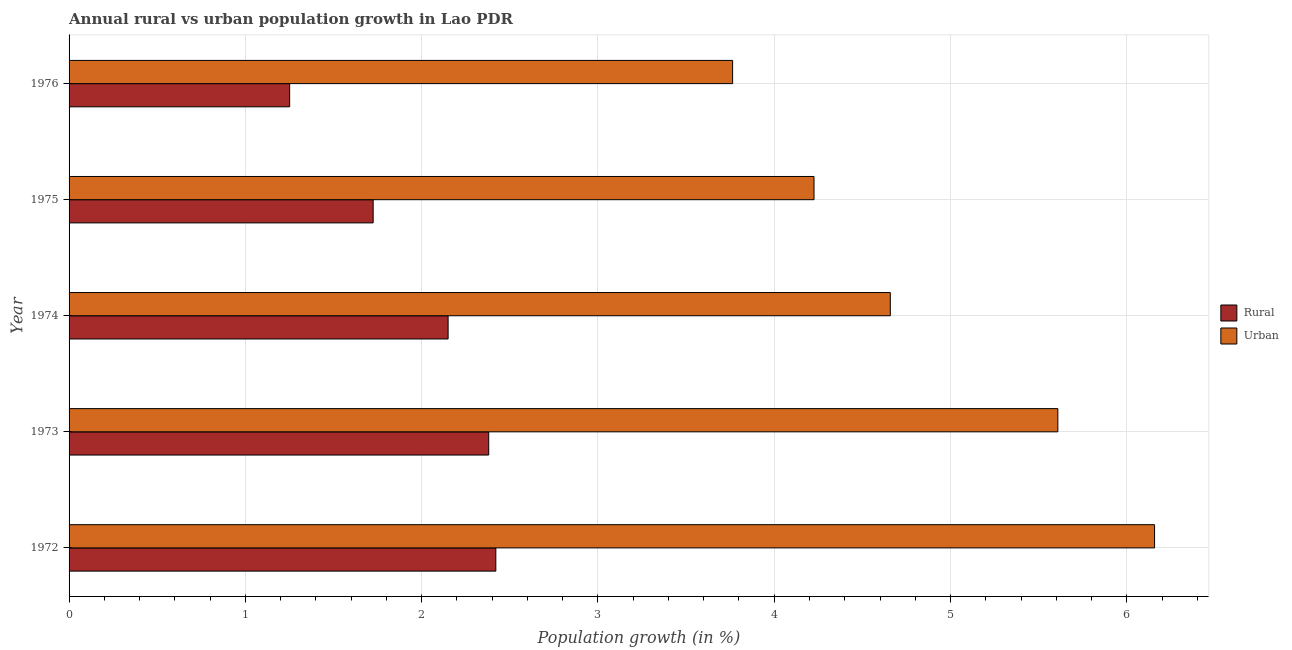How many different coloured bars are there?
Your answer should be compact. 2. How many groups of bars are there?
Make the answer very short. 5. Are the number of bars per tick equal to the number of legend labels?
Ensure brevity in your answer.  Yes. How many bars are there on the 5th tick from the top?
Your answer should be very brief. 2. What is the rural population growth in 1976?
Your answer should be compact. 1.25. Across all years, what is the maximum urban population growth?
Provide a succinct answer. 6.16. Across all years, what is the minimum urban population growth?
Your answer should be compact. 3.76. In which year was the urban population growth maximum?
Provide a short and direct response. 1972. In which year was the urban population growth minimum?
Offer a terse response. 1976. What is the total urban population growth in the graph?
Provide a succinct answer. 24.41. What is the difference between the rural population growth in 1974 and that in 1976?
Your answer should be very brief. 0.9. What is the difference between the urban population growth in 1975 and the rural population growth in 1976?
Your answer should be compact. 2.97. What is the average urban population growth per year?
Ensure brevity in your answer.  4.88. In the year 1976, what is the difference between the rural population growth and urban population growth?
Your response must be concise. -2.51. What is the ratio of the rural population growth in 1973 to that in 1975?
Your answer should be very brief. 1.38. What is the difference between the highest and the second highest urban population growth?
Your answer should be compact. 0.55. What is the difference between the highest and the lowest urban population growth?
Keep it short and to the point. 2.39. In how many years, is the urban population growth greater than the average urban population growth taken over all years?
Offer a terse response. 2. What does the 1st bar from the top in 1973 represents?
Your answer should be compact. Urban . What does the 1st bar from the bottom in 1974 represents?
Your response must be concise. Rural. How many bars are there?
Your answer should be very brief. 10. How many years are there in the graph?
Your answer should be very brief. 5. What is the difference between two consecutive major ticks on the X-axis?
Offer a very short reply. 1. Does the graph contain any zero values?
Provide a succinct answer. No. How are the legend labels stacked?
Your answer should be very brief. Vertical. What is the title of the graph?
Offer a very short reply. Annual rural vs urban population growth in Lao PDR. Does "Quasi money growth" appear as one of the legend labels in the graph?
Your answer should be very brief. No. What is the label or title of the X-axis?
Your response must be concise. Population growth (in %). What is the label or title of the Y-axis?
Provide a short and direct response. Year. What is the Population growth (in %) in Rural in 1972?
Your answer should be compact. 2.42. What is the Population growth (in %) of Urban  in 1972?
Your answer should be compact. 6.16. What is the Population growth (in %) of Rural in 1973?
Offer a very short reply. 2.38. What is the Population growth (in %) in Urban  in 1973?
Your response must be concise. 5.61. What is the Population growth (in %) in Rural in 1974?
Provide a short and direct response. 2.15. What is the Population growth (in %) in Urban  in 1974?
Give a very brief answer. 4.66. What is the Population growth (in %) of Rural in 1975?
Provide a succinct answer. 1.72. What is the Population growth (in %) of Urban  in 1975?
Provide a short and direct response. 4.23. What is the Population growth (in %) in Rural in 1976?
Your answer should be very brief. 1.25. What is the Population growth (in %) of Urban  in 1976?
Your answer should be compact. 3.76. Across all years, what is the maximum Population growth (in %) in Rural?
Your answer should be compact. 2.42. Across all years, what is the maximum Population growth (in %) of Urban ?
Keep it short and to the point. 6.16. Across all years, what is the minimum Population growth (in %) in Rural?
Offer a terse response. 1.25. Across all years, what is the minimum Population growth (in %) of Urban ?
Keep it short and to the point. 3.76. What is the total Population growth (in %) in Rural in the graph?
Offer a very short reply. 9.93. What is the total Population growth (in %) of Urban  in the graph?
Provide a short and direct response. 24.41. What is the difference between the Population growth (in %) of Rural in 1972 and that in 1973?
Offer a terse response. 0.04. What is the difference between the Population growth (in %) of Urban  in 1972 and that in 1973?
Offer a terse response. 0.55. What is the difference between the Population growth (in %) of Rural in 1972 and that in 1974?
Make the answer very short. 0.27. What is the difference between the Population growth (in %) of Urban  in 1972 and that in 1974?
Keep it short and to the point. 1.5. What is the difference between the Population growth (in %) in Rural in 1972 and that in 1975?
Keep it short and to the point. 0.7. What is the difference between the Population growth (in %) of Urban  in 1972 and that in 1975?
Your response must be concise. 1.93. What is the difference between the Population growth (in %) of Rural in 1972 and that in 1976?
Offer a terse response. 1.17. What is the difference between the Population growth (in %) of Urban  in 1972 and that in 1976?
Provide a succinct answer. 2.39. What is the difference between the Population growth (in %) of Rural in 1973 and that in 1974?
Your response must be concise. 0.23. What is the difference between the Population growth (in %) in Urban  in 1973 and that in 1974?
Provide a short and direct response. 0.95. What is the difference between the Population growth (in %) in Rural in 1973 and that in 1975?
Ensure brevity in your answer.  0.66. What is the difference between the Population growth (in %) in Urban  in 1973 and that in 1975?
Provide a short and direct response. 1.38. What is the difference between the Population growth (in %) of Rural in 1973 and that in 1976?
Your response must be concise. 1.13. What is the difference between the Population growth (in %) of Urban  in 1973 and that in 1976?
Your answer should be compact. 1.84. What is the difference between the Population growth (in %) of Rural in 1974 and that in 1975?
Provide a short and direct response. 0.43. What is the difference between the Population growth (in %) of Urban  in 1974 and that in 1975?
Ensure brevity in your answer.  0.43. What is the difference between the Population growth (in %) in Rural in 1974 and that in 1976?
Your response must be concise. 0.9. What is the difference between the Population growth (in %) in Urban  in 1974 and that in 1976?
Provide a short and direct response. 0.89. What is the difference between the Population growth (in %) in Rural in 1975 and that in 1976?
Offer a terse response. 0.47. What is the difference between the Population growth (in %) in Urban  in 1975 and that in 1976?
Give a very brief answer. 0.46. What is the difference between the Population growth (in %) in Rural in 1972 and the Population growth (in %) in Urban  in 1973?
Provide a short and direct response. -3.19. What is the difference between the Population growth (in %) in Rural in 1972 and the Population growth (in %) in Urban  in 1974?
Ensure brevity in your answer.  -2.24. What is the difference between the Population growth (in %) in Rural in 1972 and the Population growth (in %) in Urban  in 1975?
Your answer should be compact. -1.8. What is the difference between the Population growth (in %) of Rural in 1972 and the Population growth (in %) of Urban  in 1976?
Keep it short and to the point. -1.34. What is the difference between the Population growth (in %) of Rural in 1973 and the Population growth (in %) of Urban  in 1974?
Your answer should be compact. -2.28. What is the difference between the Population growth (in %) in Rural in 1973 and the Population growth (in %) in Urban  in 1975?
Keep it short and to the point. -1.85. What is the difference between the Population growth (in %) of Rural in 1973 and the Population growth (in %) of Urban  in 1976?
Provide a short and direct response. -1.38. What is the difference between the Population growth (in %) of Rural in 1974 and the Population growth (in %) of Urban  in 1975?
Provide a succinct answer. -2.08. What is the difference between the Population growth (in %) in Rural in 1974 and the Population growth (in %) in Urban  in 1976?
Offer a very short reply. -1.61. What is the difference between the Population growth (in %) of Rural in 1975 and the Population growth (in %) of Urban  in 1976?
Keep it short and to the point. -2.04. What is the average Population growth (in %) in Rural per year?
Offer a terse response. 1.99. What is the average Population growth (in %) of Urban  per year?
Ensure brevity in your answer.  4.88. In the year 1972, what is the difference between the Population growth (in %) in Rural and Population growth (in %) in Urban ?
Offer a very short reply. -3.74. In the year 1973, what is the difference between the Population growth (in %) in Rural and Population growth (in %) in Urban ?
Make the answer very short. -3.23. In the year 1974, what is the difference between the Population growth (in %) in Rural and Population growth (in %) in Urban ?
Offer a terse response. -2.51. In the year 1975, what is the difference between the Population growth (in %) of Rural and Population growth (in %) of Urban ?
Provide a succinct answer. -2.5. In the year 1976, what is the difference between the Population growth (in %) of Rural and Population growth (in %) of Urban ?
Offer a terse response. -2.51. What is the ratio of the Population growth (in %) of Rural in 1972 to that in 1973?
Offer a terse response. 1.02. What is the ratio of the Population growth (in %) in Urban  in 1972 to that in 1973?
Your answer should be very brief. 1.1. What is the ratio of the Population growth (in %) in Rural in 1972 to that in 1974?
Ensure brevity in your answer.  1.13. What is the ratio of the Population growth (in %) in Urban  in 1972 to that in 1974?
Your response must be concise. 1.32. What is the ratio of the Population growth (in %) of Rural in 1972 to that in 1975?
Your response must be concise. 1.4. What is the ratio of the Population growth (in %) in Urban  in 1972 to that in 1975?
Ensure brevity in your answer.  1.46. What is the ratio of the Population growth (in %) in Rural in 1972 to that in 1976?
Your answer should be very brief. 1.93. What is the ratio of the Population growth (in %) in Urban  in 1972 to that in 1976?
Give a very brief answer. 1.64. What is the ratio of the Population growth (in %) of Rural in 1973 to that in 1974?
Keep it short and to the point. 1.11. What is the ratio of the Population growth (in %) of Urban  in 1973 to that in 1974?
Give a very brief answer. 1.2. What is the ratio of the Population growth (in %) in Rural in 1973 to that in 1975?
Provide a short and direct response. 1.38. What is the ratio of the Population growth (in %) of Urban  in 1973 to that in 1975?
Your response must be concise. 1.33. What is the ratio of the Population growth (in %) in Rural in 1973 to that in 1976?
Keep it short and to the point. 1.9. What is the ratio of the Population growth (in %) of Urban  in 1973 to that in 1976?
Give a very brief answer. 1.49. What is the ratio of the Population growth (in %) of Rural in 1974 to that in 1975?
Offer a terse response. 1.25. What is the ratio of the Population growth (in %) of Urban  in 1974 to that in 1975?
Offer a terse response. 1.1. What is the ratio of the Population growth (in %) in Rural in 1974 to that in 1976?
Make the answer very short. 1.72. What is the ratio of the Population growth (in %) in Urban  in 1974 to that in 1976?
Provide a short and direct response. 1.24. What is the ratio of the Population growth (in %) of Rural in 1975 to that in 1976?
Give a very brief answer. 1.38. What is the ratio of the Population growth (in %) of Urban  in 1975 to that in 1976?
Your answer should be compact. 1.12. What is the difference between the highest and the second highest Population growth (in %) in Rural?
Keep it short and to the point. 0.04. What is the difference between the highest and the second highest Population growth (in %) of Urban ?
Your answer should be very brief. 0.55. What is the difference between the highest and the lowest Population growth (in %) of Rural?
Provide a succinct answer. 1.17. What is the difference between the highest and the lowest Population growth (in %) in Urban ?
Give a very brief answer. 2.39. 